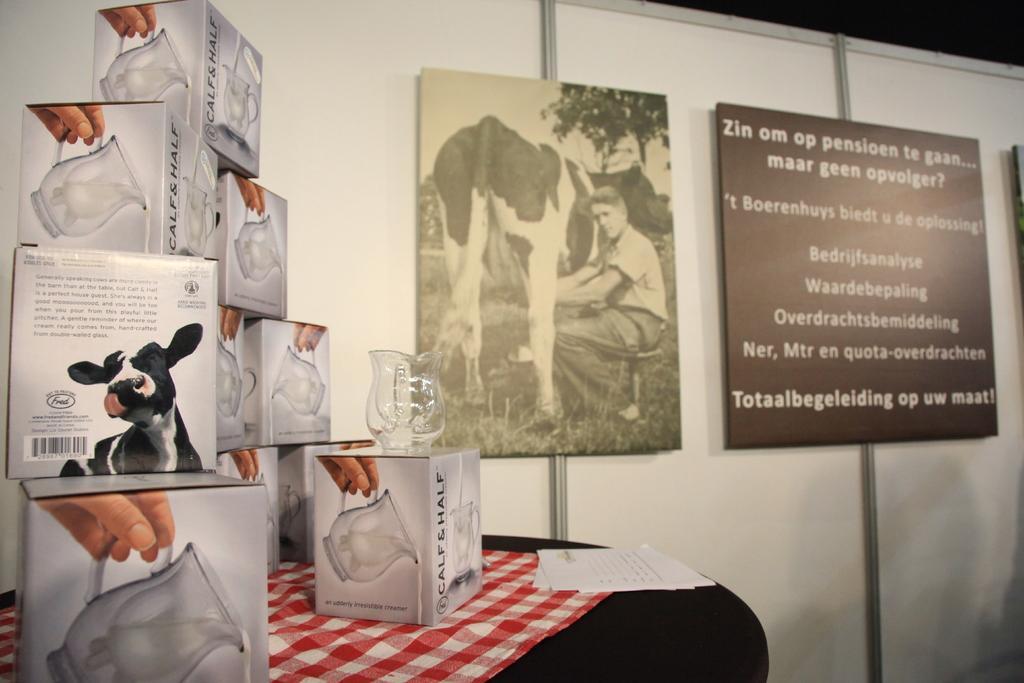Describe this image in one or two sentences. In this image we can see a black surface. On that there is a cloth and papers. Also there are boxes. On the box there is a jar. In the back there is a wall with boards. On one board something is written. On another board we can see a person milking a cow. 